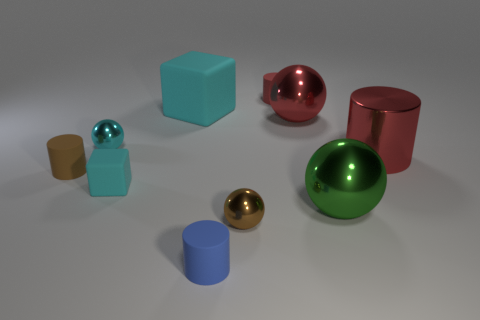There is a small object that is the same shape as the large cyan rubber object; what is its material?
Offer a very short reply. Rubber. Is the number of big cyan objects that are behind the tiny cyan rubber object the same as the number of red shiny balls behind the big rubber block?
Ensure brevity in your answer.  No. Is the tiny cyan block made of the same material as the blue cylinder?
Make the answer very short. Yes. How many brown things are either things or tiny cubes?
Your response must be concise. 2. What number of large red shiny things are the same shape as the green shiny object?
Your answer should be very brief. 1. What is the material of the tiny red cylinder?
Provide a short and direct response. Rubber. Are there the same number of tiny brown rubber objects behind the big cylinder and tiny green shiny cylinders?
Your response must be concise. Yes. There is a brown metal thing that is the same size as the blue thing; what shape is it?
Make the answer very short. Sphere. Is there a small matte object that is left of the large red object behind the small cyan metallic sphere?
Your response must be concise. Yes. How many tiny things are brown metal cubes or cyan cubes?
Keep it short and to the point. 1. 